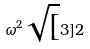Convert formula to latex. <formula><loc_0><loc_0><loc_500><loc_500>\omega ^ { 2 } \sqrt { [ } 3 ] { 2 }</formula> 